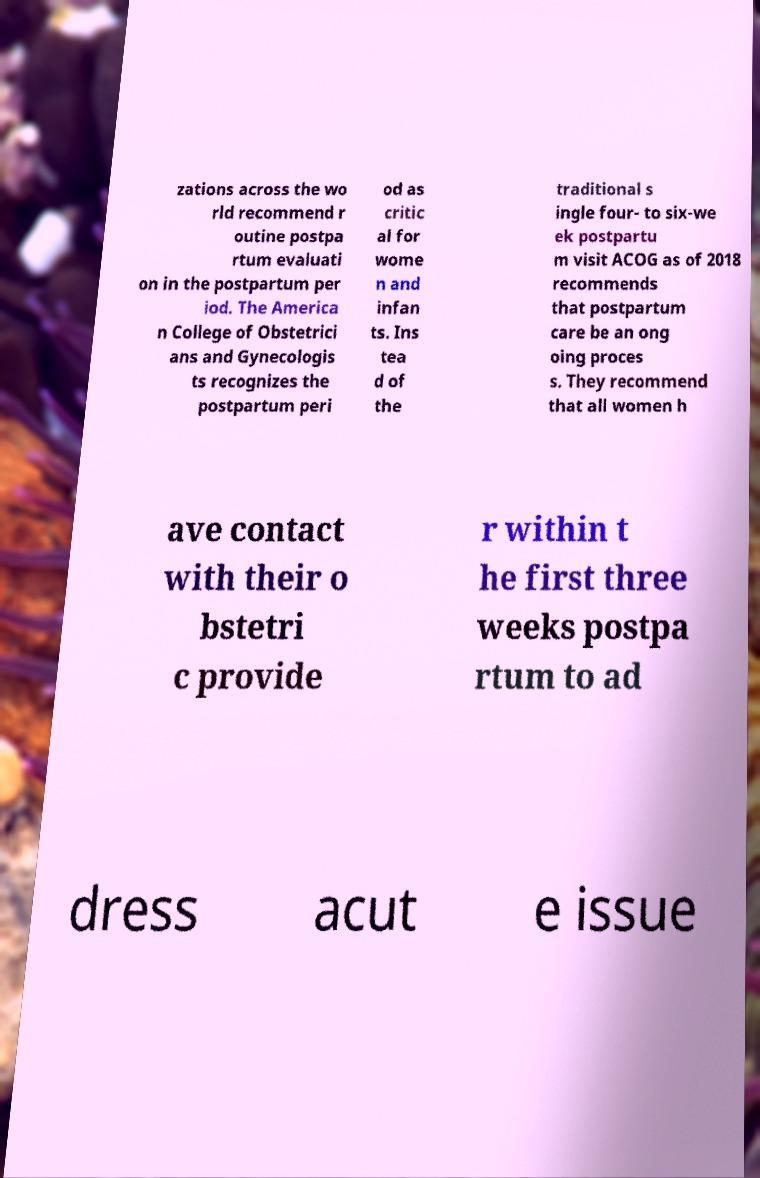Can you accurately transcribe the text from the provided image for me? zations across the wo rld recommend r outine postpa rtum evaluati on in the postpartum per iod. The America n College of Obstetrici ans and Gynecologis ts recognizes the postpartum peri od as critic al for wome n and infan ts. Ins tea d of the traditional s ingle four- to six-we ek postpartu m visit ACOG as of 2018 recommends that postpartum care be an ong oing proces s. They recommend that all women h ave contact with their o bstetri c provide r within t he first three weeks postpa rtum to ad dress acut e issue 